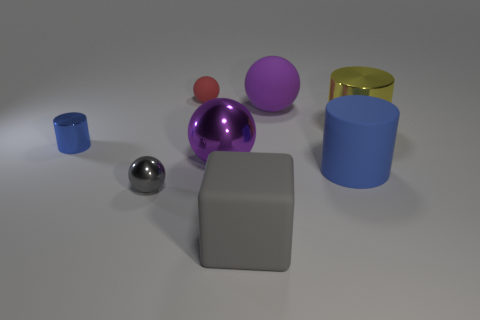Can you describe the lighting in the image? The lighting in the image is soft and diffused, producing gentle shadows and highlighting the objects without causing any harsh reflections, except for the silver sphere, which reflects its surroundings due to its glossy surface. 